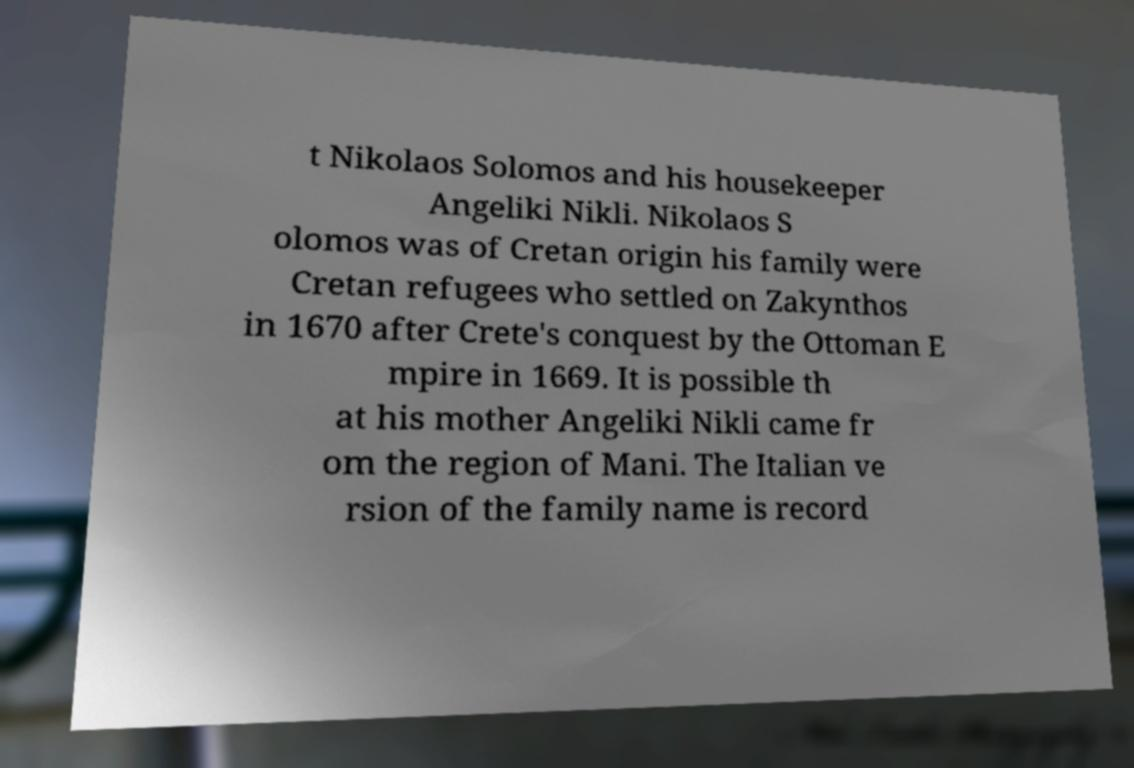There's text embedded in this image that I need extracted. Can you transcribe it verbatim? t Nikolaos Solomos and his housekeeper Angeliki Nikli. Nikolaos S olomos was of Cretan origin his family were Cretan refugees who settled on Zakynthos in 1670 after Crete's conquest by the Ottoman E mpire in 1669. It is possible th at his mother Angeliki Nikli came fr om the region of Mani. The Italian ve rsion of the family name is record 